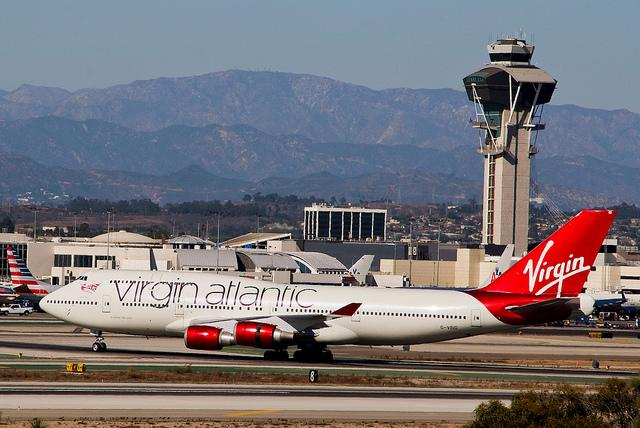What famous billionaire started the Virgin airline company? Please explain your reasoning. richard branson. The person is branson. 